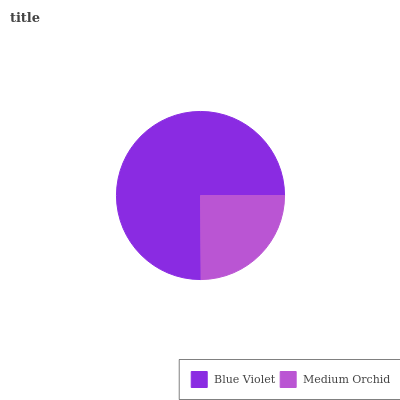Is Medium Orchid the minimum?
Answer yes or no. Yes. Is Blue Violet the maximum?
Answer yes or no. Yes. Is Medium Orchid the maximum?
Answer yes or no. No. Is Blue Violet greater than Medium Orchid?
Answer yes or no. Yes. Is Medium Orchid less than Blue Violet?
Answer yes or no. Yes. Is Medium Orchid greater than Blue Violet?
Answer yes or no. No. Is Blue Violet less than Medium Orchid?
Answer yes or no. No. Is Blue Violet the high median?
Answer yes or no. Yes. Is Medium Orchid the low median?
Answer yes or no. Yes. Is Medium Orchid the high median?
Answer yes or no. No. Is Blue Violet the low median?
Answer yes or no. No. 